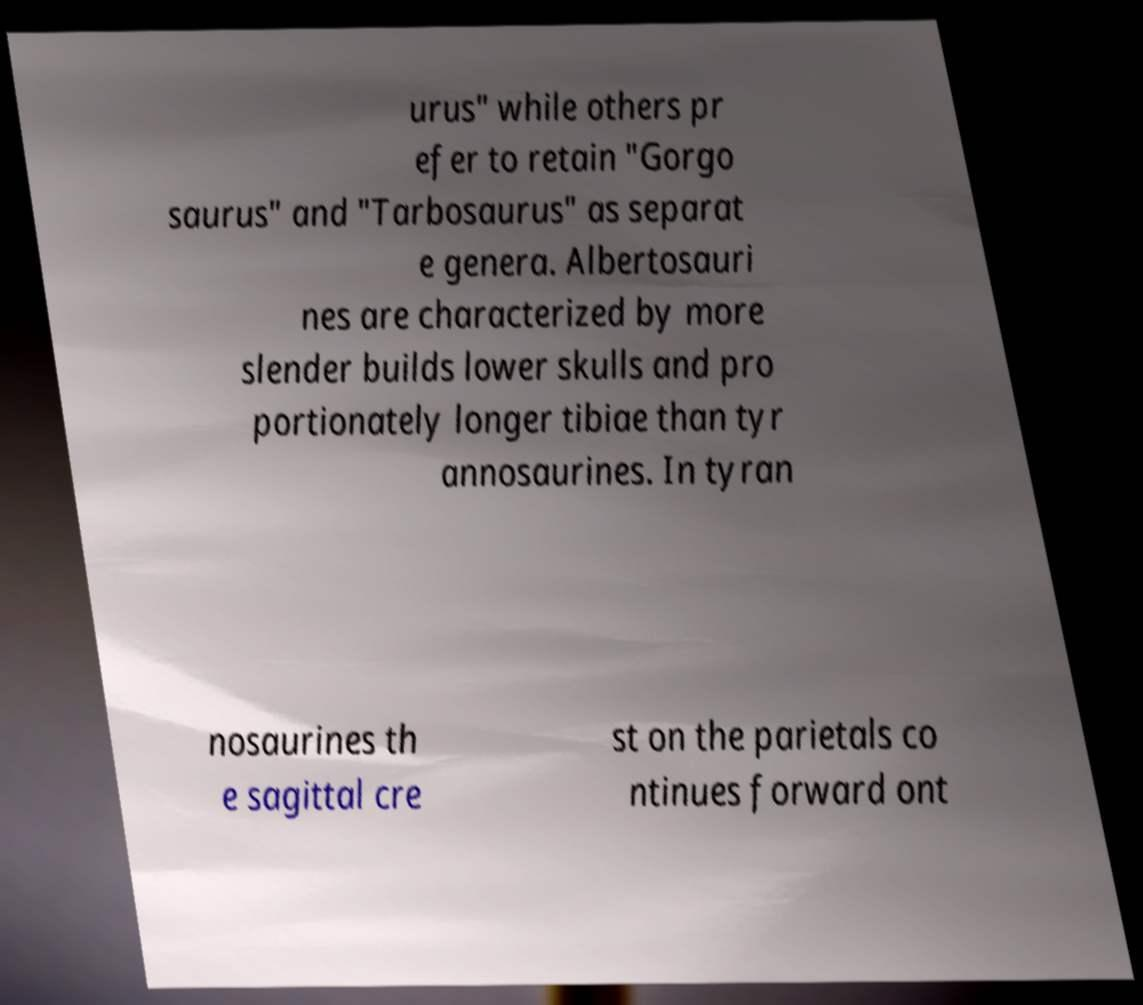There's text embedded in this image that I need extracted. Can you transcribe it verbatim? urus" while others pr efer to retain "Gorgo saurus" and "Tarbosaurus" as separat e genera. Albertosauri nes are characterized by more slender builds lower skulls and pro portionately longer tibiae than tyr annosaurines. In tyran nosaurines th e sagittal cre st on the parietals co ntinues forward ont 